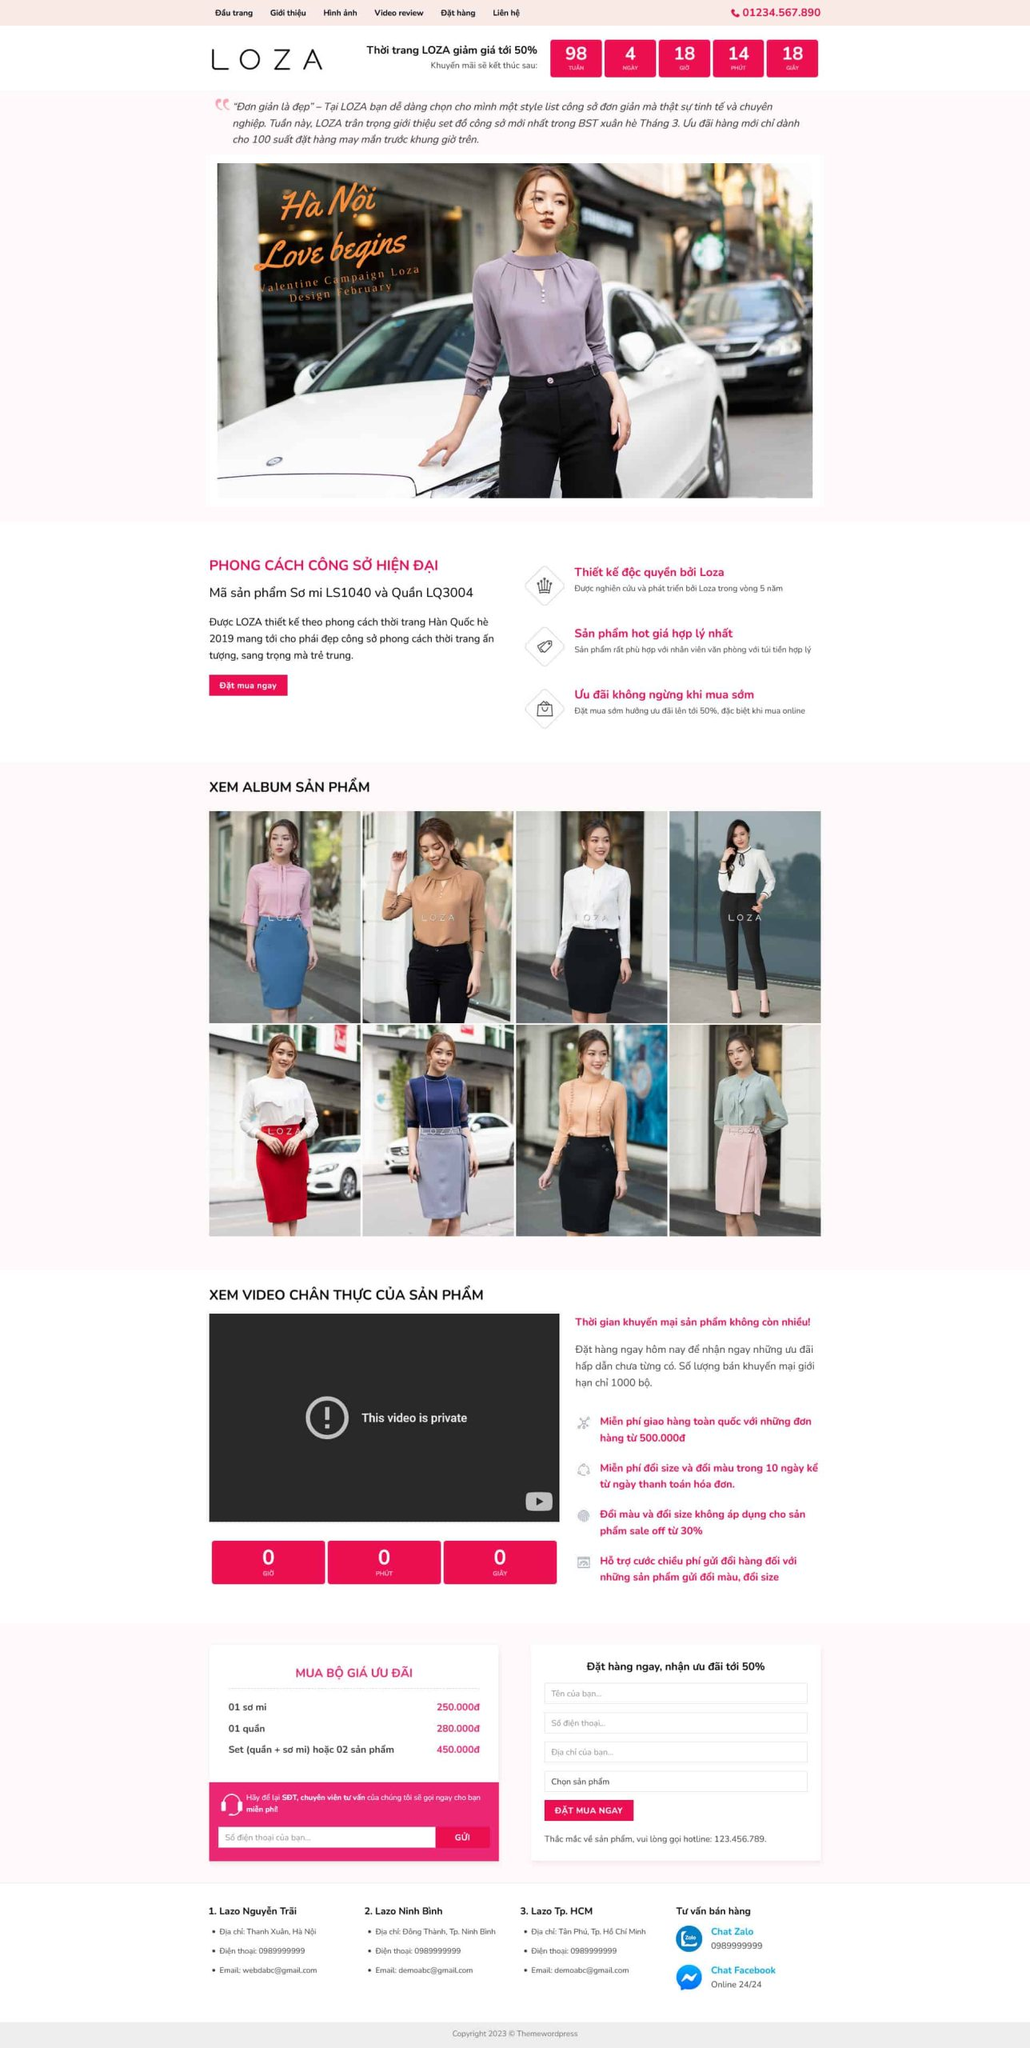Liệt kê 5 ngành nghề, lĩnh vực phù hợp với website này, phân cách các màu sắc bằng dấu phẩy. Chỉ trả về kết quả, phân cách bằng dấy phẩy
 Thời trang, Bán lẻ, Thương mại điện tử, Marketing, Dịch vụ khách hàng 